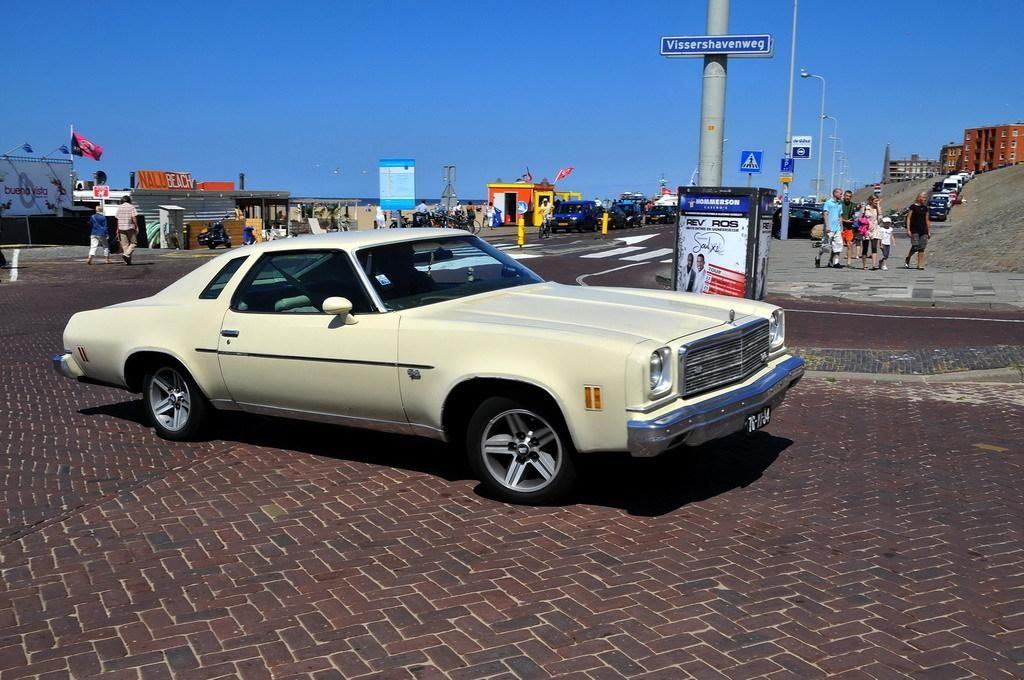What is the main subject in the center of the image? There is a car in the center of the image. Where is the car located? The car is on the road. What can be seen in the background of the image? In the background of the image, there are persons, poles, buildings, vehicles, a flag, advertisements, sand, and the sky. What type of shame is being experienced by the army in the image? There is no army or any indication of shame present in the image. 